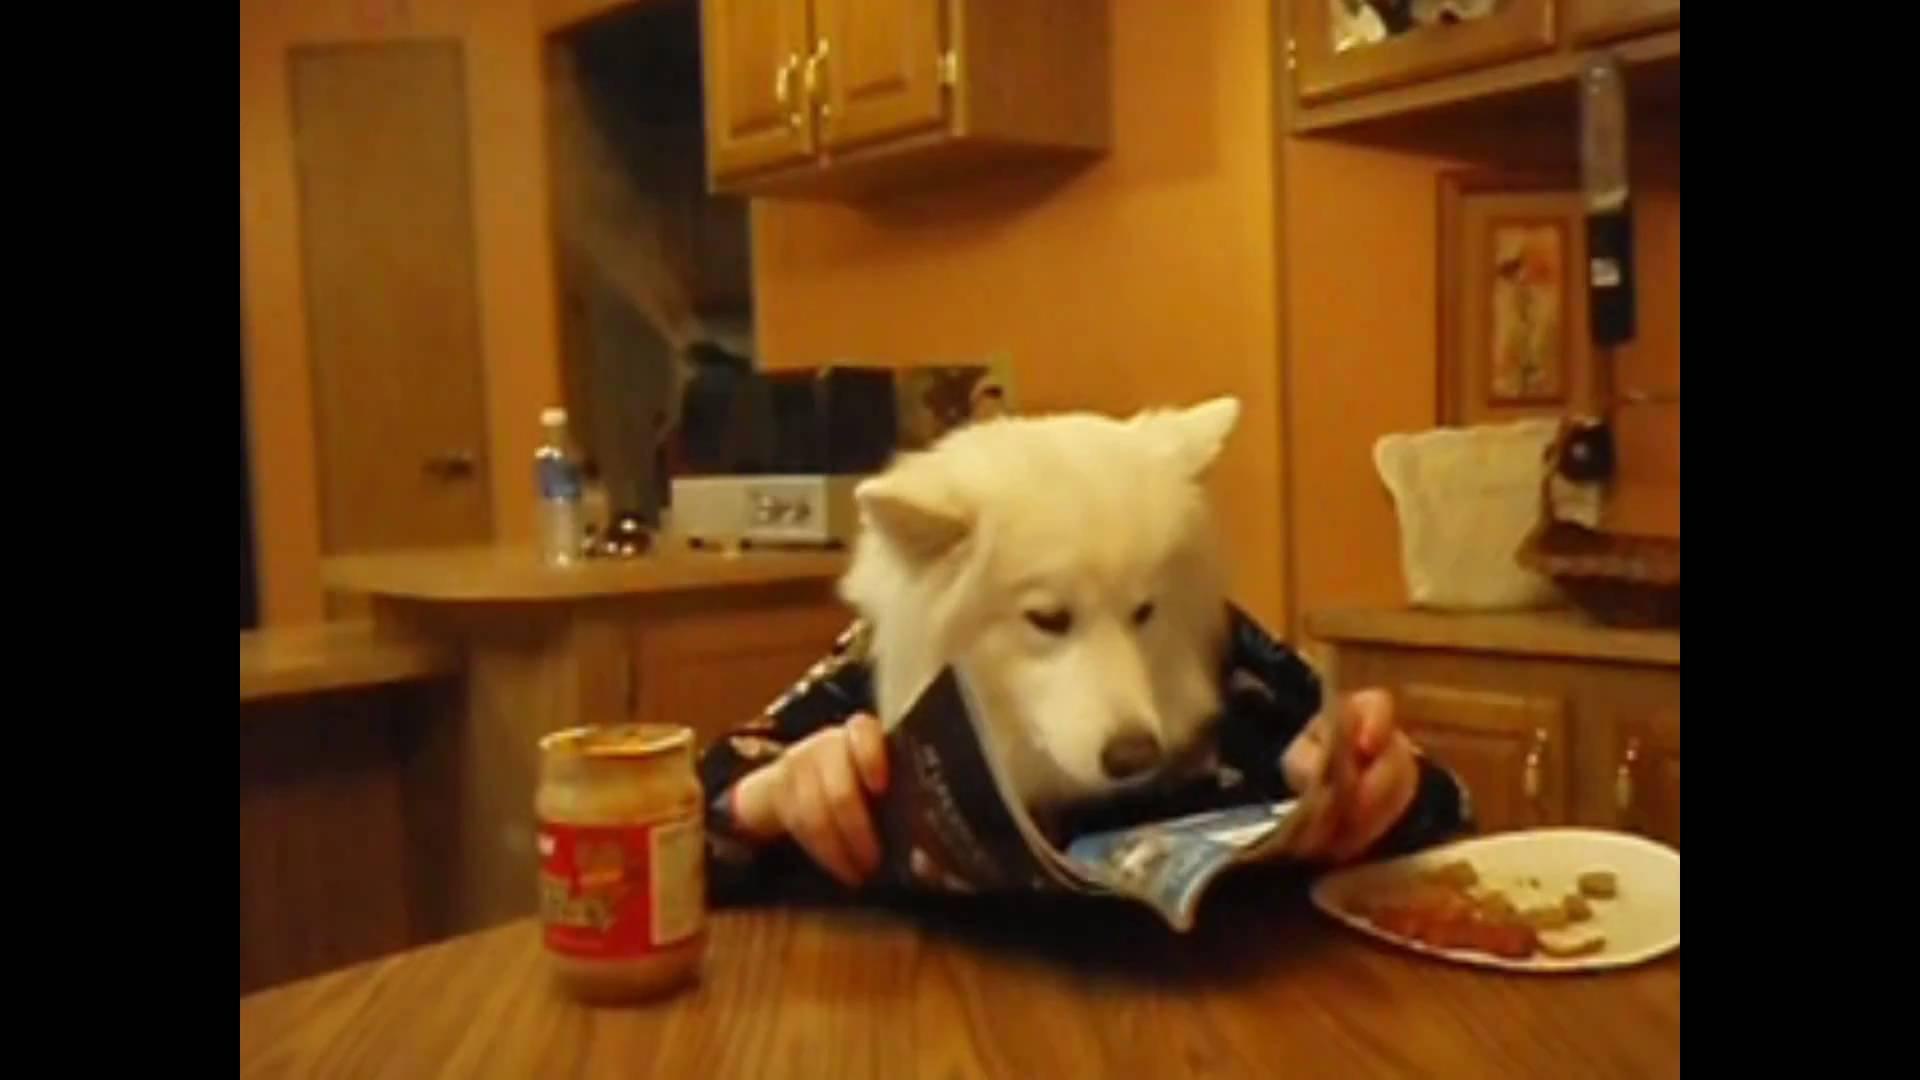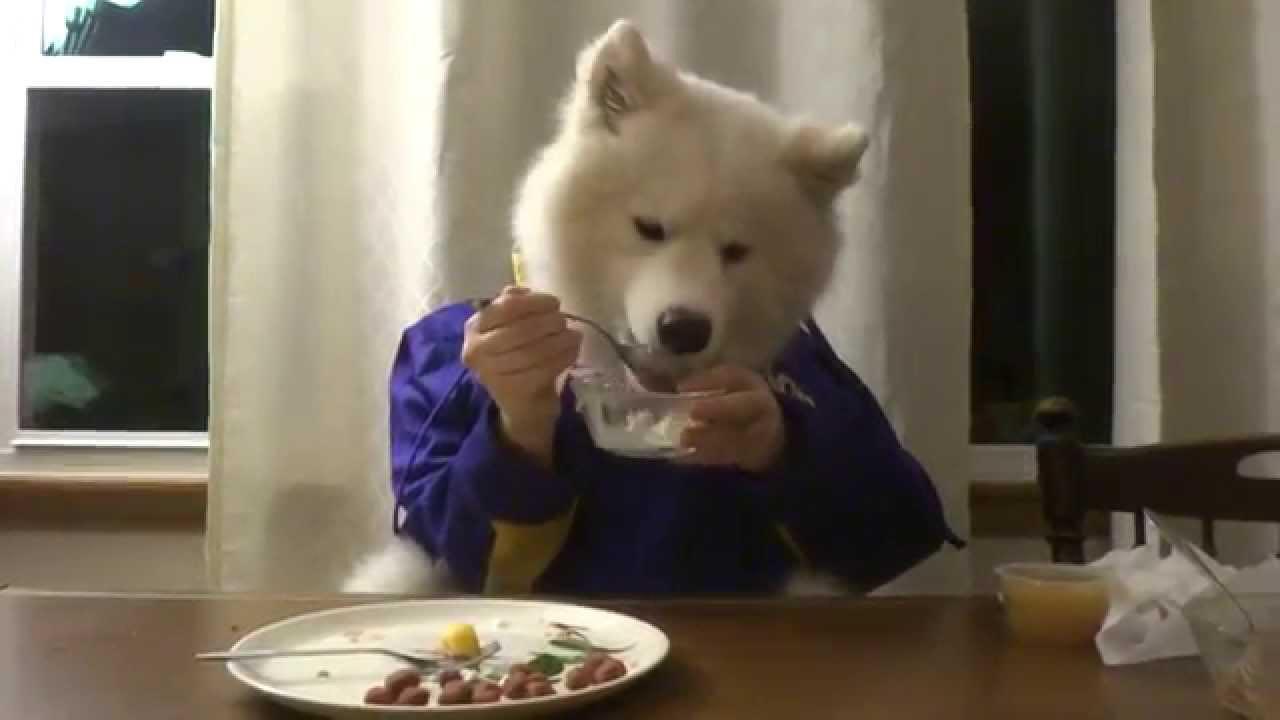The first image is the image on the left, the second image is the image on the right. Assess this claim about the two images: "An image shows a person's hand reaching from the right to offer something tasty to a white dog.". Correct or not? Answer yes or no. No. 